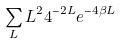<formula> <loc_0><loc_0><loc_500><loc_500>\sum _ { L } L ^ { 2 } 4 ^ { - 2 L } e ^ { - 4 \beta L }</formula> 